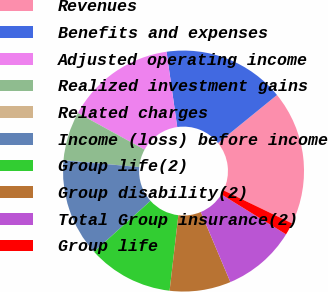<chart> <loc_0><loc_0><loc_500><loc_500><pie_chart><fcel>Revenues<fcel>Benefits and expenses<fcel>Adjusted operating income<fcel>Realized investment gains<fcel>Related charges<fcel>Income (loss) before income<fcel>Group life(2)<fcel>Group disability(2)<fcel>Total Group insurance(2)<fcel>Group life<nl><fcel>18.02%<fcel>16.38%<fcel>14.75%<fcel>6.56%<fcel>0.01%<fcel>13.11%<fcel>11.47%<fcel>8.2%<fcel>9.84%<fcel>1.65%<nl></chart> 